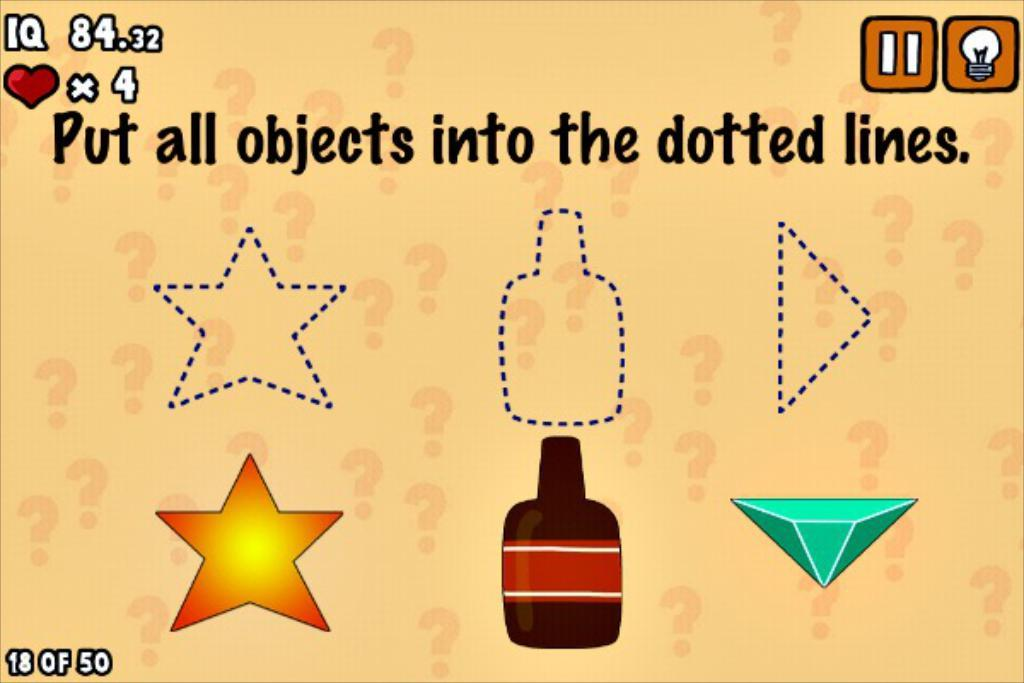<image>
Share a concise interpretation of the image provided. You have four lives to place three different objects into their respective dotted line cut-outs. 